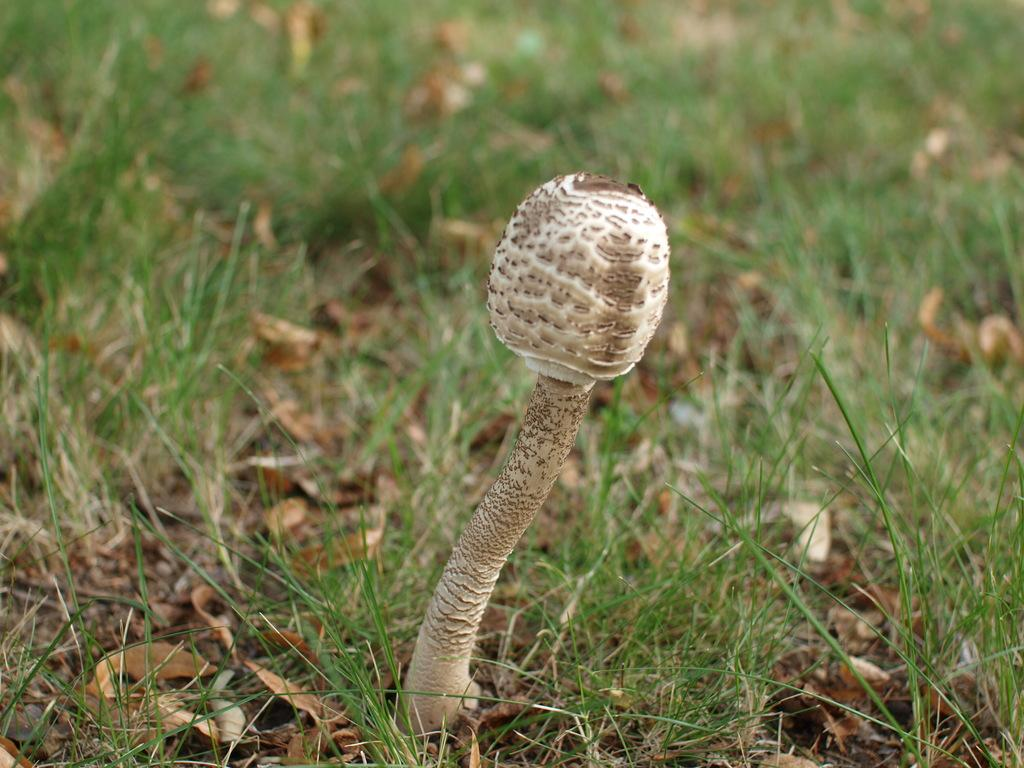What type of plant is visible in the image? There is a mushroom in the image. What type of vegetation is present at the bottom of the image? There is grass at the bottom of the image. What type of plant material can be seen in the image? There are dried leaves in the image. What type of memory can be seen in the image? There is no memory present in the image; it features a mushroom, grass, and dried leaves. What type of wave can be seen in the image? There is no wave present in the image; it features a mushroom, grass, and dried leaves. 